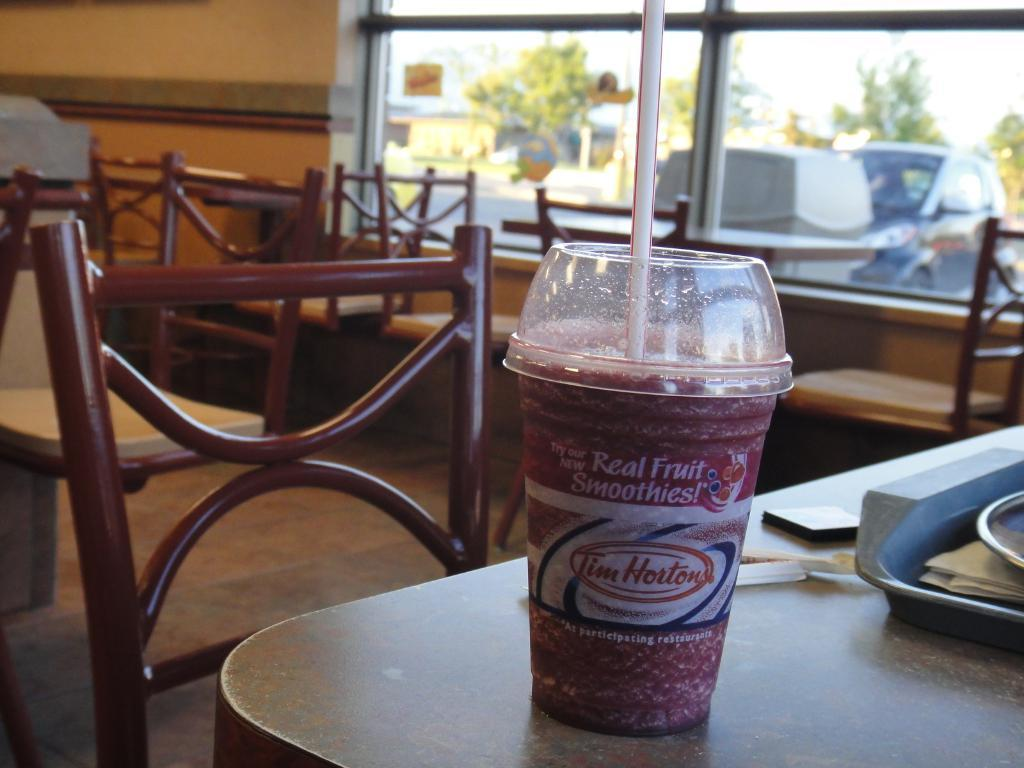What is on the table in the image? There is a glass with a straw on a table. What else is on the table besides the glass? There is a tray on the table. How many chairs are visible in the image? There are multiple chairs in the image. What can be seen through the window in the image? Vehicles and trees are visible outside the window. Where are the ants in the image? There are no ants present in the image. What type of medical advice can be obtained from the doctor in the image? There is no doctor present in the image. 